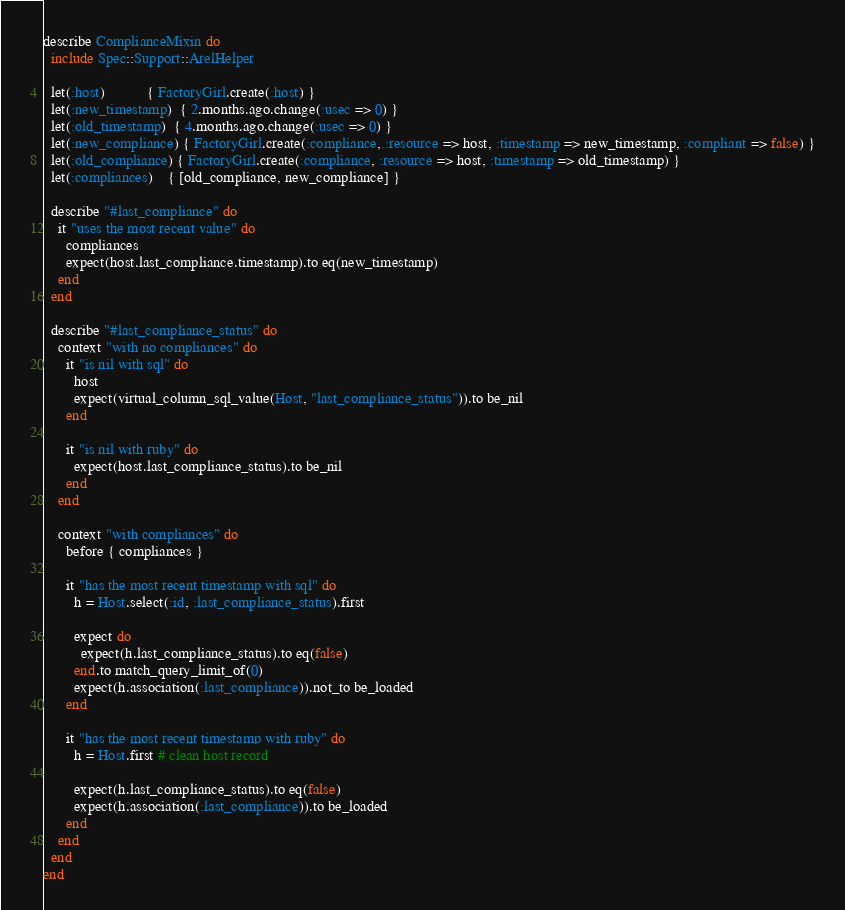Convert code to text. <code><loc_0><loc_0><loc_500><loc_500><_Ruby_>describe ComplianceMixin do
  include Spec::Support::ArelHelper

  let(:host)           { FactoryGirl.create(:host) }
  let(:new_timestamp)  { 2.months.ago.change(:usec => 0) }
  let(:old_timestamp)  { 4.months.ago.change(:usec => 0) }
  let(:new_compliance) { FactoryGirl.create(:compliance, :resource => host, :timestamp => new_timestamp, :compliant => false) }
  let(:old_compliance) { FactoryGirl.create(:compliance, :resource => host, :timestamp => old_timestamp) }
  let(:compliances)    { [old_compliance, new_compliance] }

  describe "#last_compliance" do
    it "uses the most recent value" do
      compliances
      expect(host.last_compliance.timestamp).to eq(new_timestamp)
    end
  end

  describe "#last_compliance_status" do
    context "with no compliances" do
      it "is nil with sql" do
        host
        expect(virtual_column_sql_value(Host, "last_compliance_status")).to be_nil
      end

      it "is nil with ruby" do
        expect(host.last_compliance_status).to be_nil
      end
    end

    context "with compliances" do
      before { compliances }

      it "has the most recent timestamp with sql" do
        h = Host.select(:id, :last_compliance_status).first

        expect do
          expect(h.last_compliance_status).to eq(false)
        end.to match_query_limit_of(0)
        expect(h.association(:last_compliance)).not_to be_loaded
      end

      it "has the most recent timestamp with ruby" do
        h = Host.first # clean host record

        expect(h.last_compliance_status).to eq(false)
        expect(h.association(:last_compliance)).to be_loaded
      end
    end
  end
end
</code> 